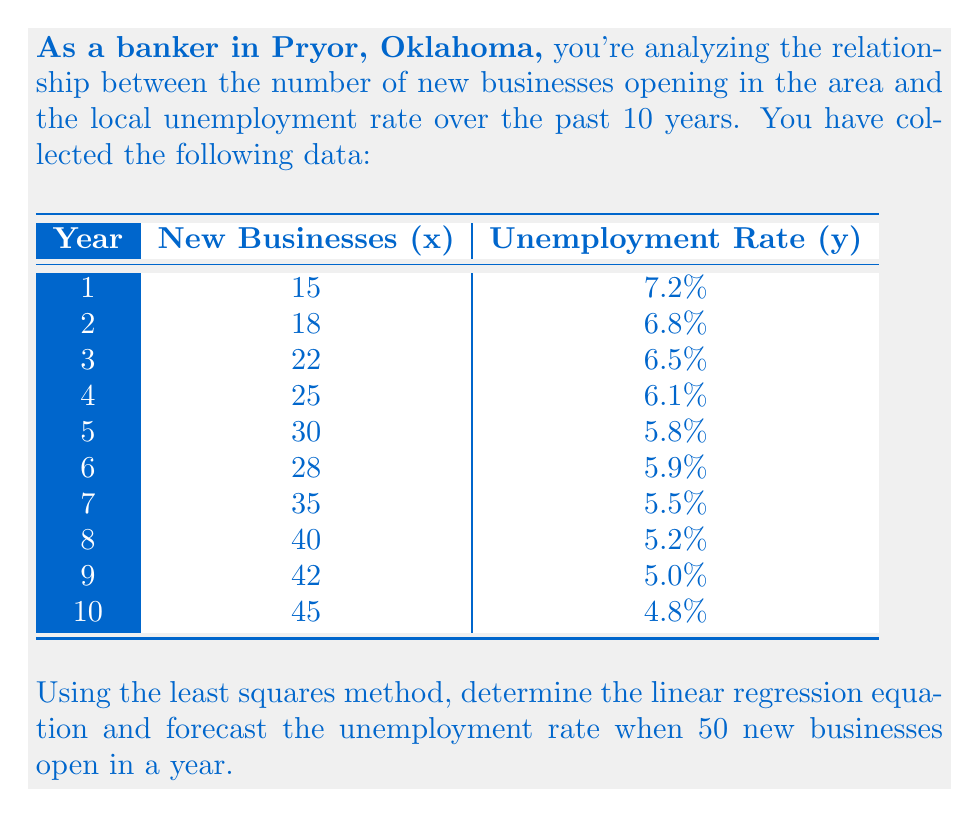Solve this math problem. To solve this problem, we'll use the least squares method to find the linear regression equation in the form $y = mx + b$, where $m$ is the slope and $b$ is the y-intercept.

Step 1: Calculate the sums needed for the least squares formulas.
$$\sum x = 300, \sum y = 58.8, \sum xy = 1731, \sum x^2 = 10,174, n = 10$$

Step 2: Calculate the slope $m$ using the formula:
$$m = \frac{n\sum xy - \sum x \sum y}{n\sum x^2 - (\sum x)^2}$$
$$m = \frac{10(1731) - 300(58.8)}{10(10,174) - 300^2} = \frac{17310 - 17640}{101740 - 90000} = \frac{-330}{11740} = -0.0281$$

Step 3: Calculate the y-intercept $b$ using the formula:
$$b = \frac{\sum y - m\sum x}{n}$$
$$b = \frac{58.8 - (-0.0281)(300)}{10} = \frac{58.8 + 8.43}{10} = 6.723$$

Step 4: Form the linear regression equation:
$$y = -0.0281x + 6.723$$

Step 5: Forecast the unemployment rate when 50 new businesses open (x = 50):
$$y = -0.0281(50) + 6.723 = 5.318$$

Therefore, the forecasted unemployment rate when 50 new businesses open is approximately 5.32%.
Answer: $y = -0.0281x + 6.723$; 5.32% 